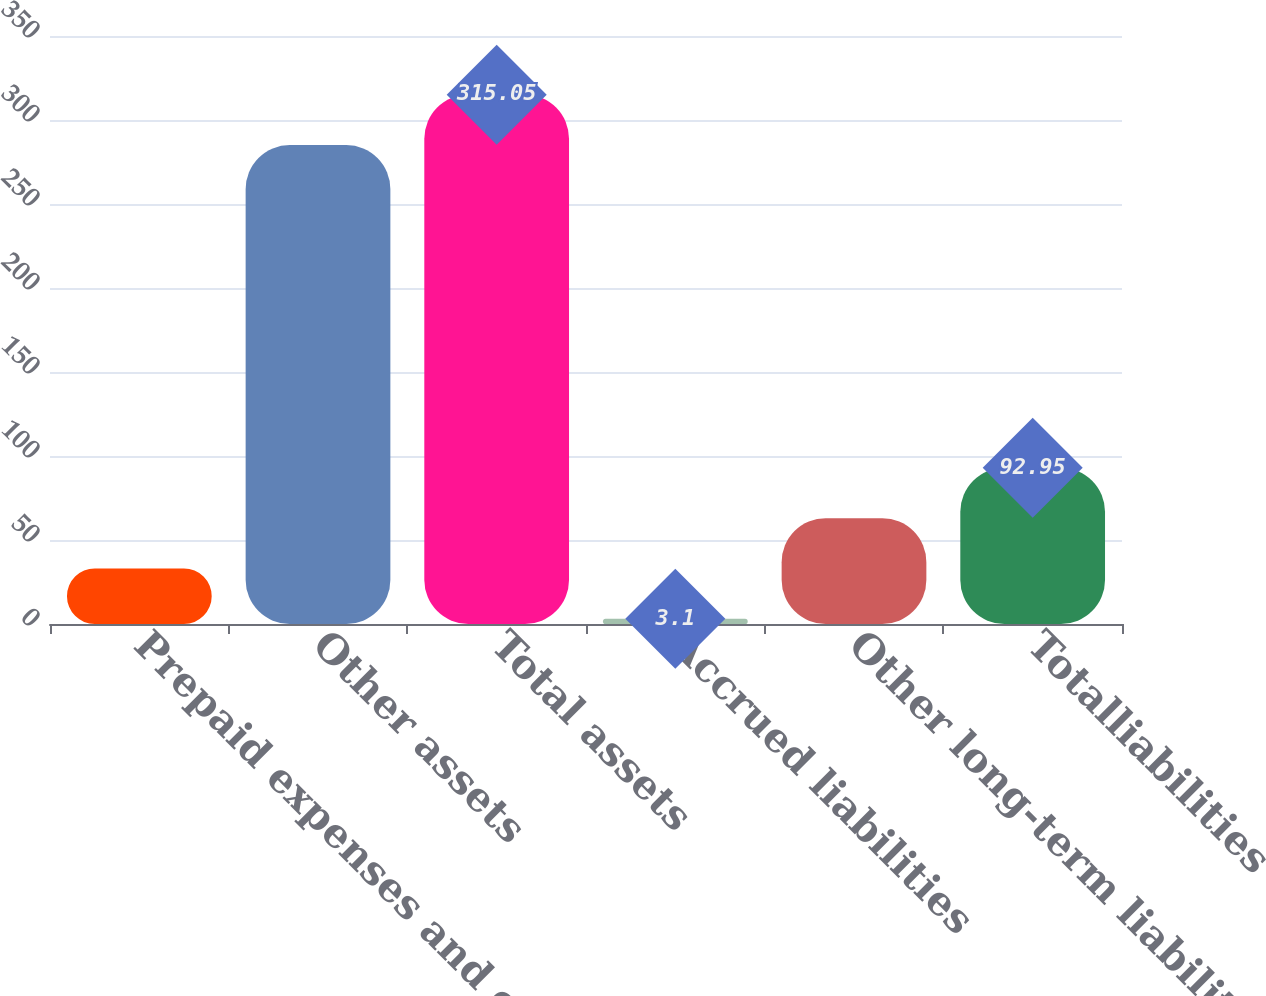Convert chart. <chart><loc_0><loc_0><loc_500><loc_500><bar_chart><fcel>Prepaid expenses and other<fcel>Other assets<fcel>Total assets<fcel>Accrued liabilities<fcel>Other long-term liabilities<fcel>Totalliabilities<nl><fcel>33.05<fcel>285.1<fcel>315.05<fcel>3.1<fcel>63<fcel>92.95<nl></chart> 